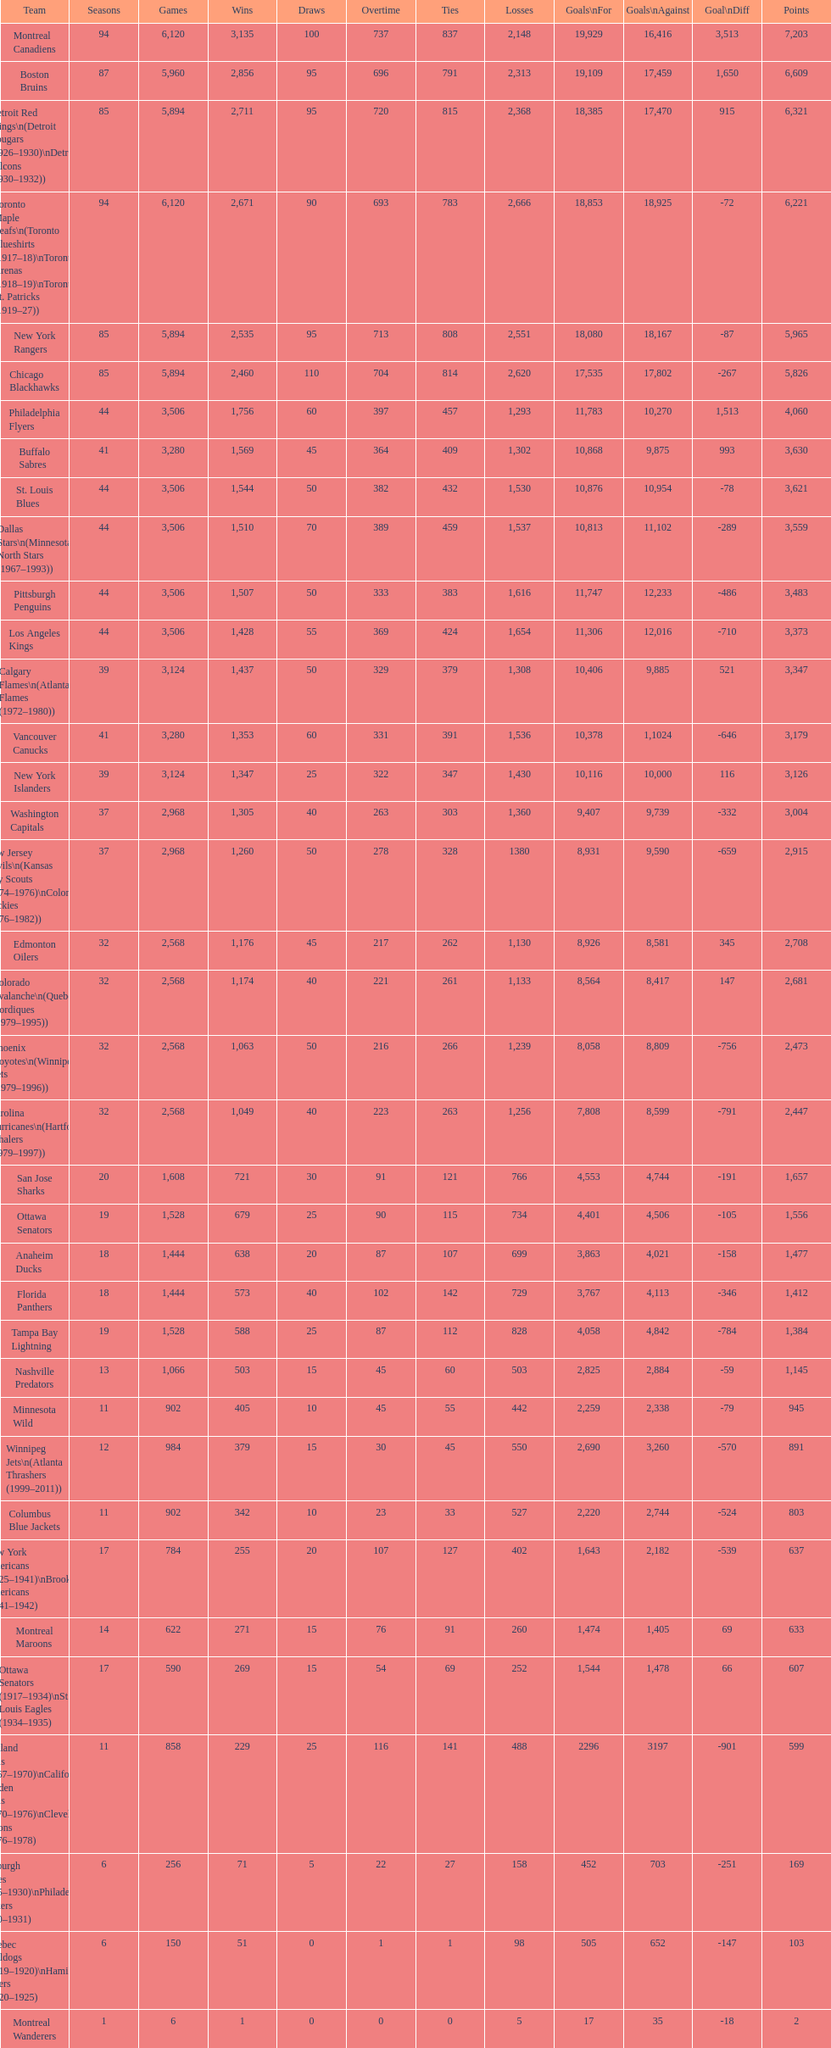Who has the least amount of losses? Montreal Wanderers. 